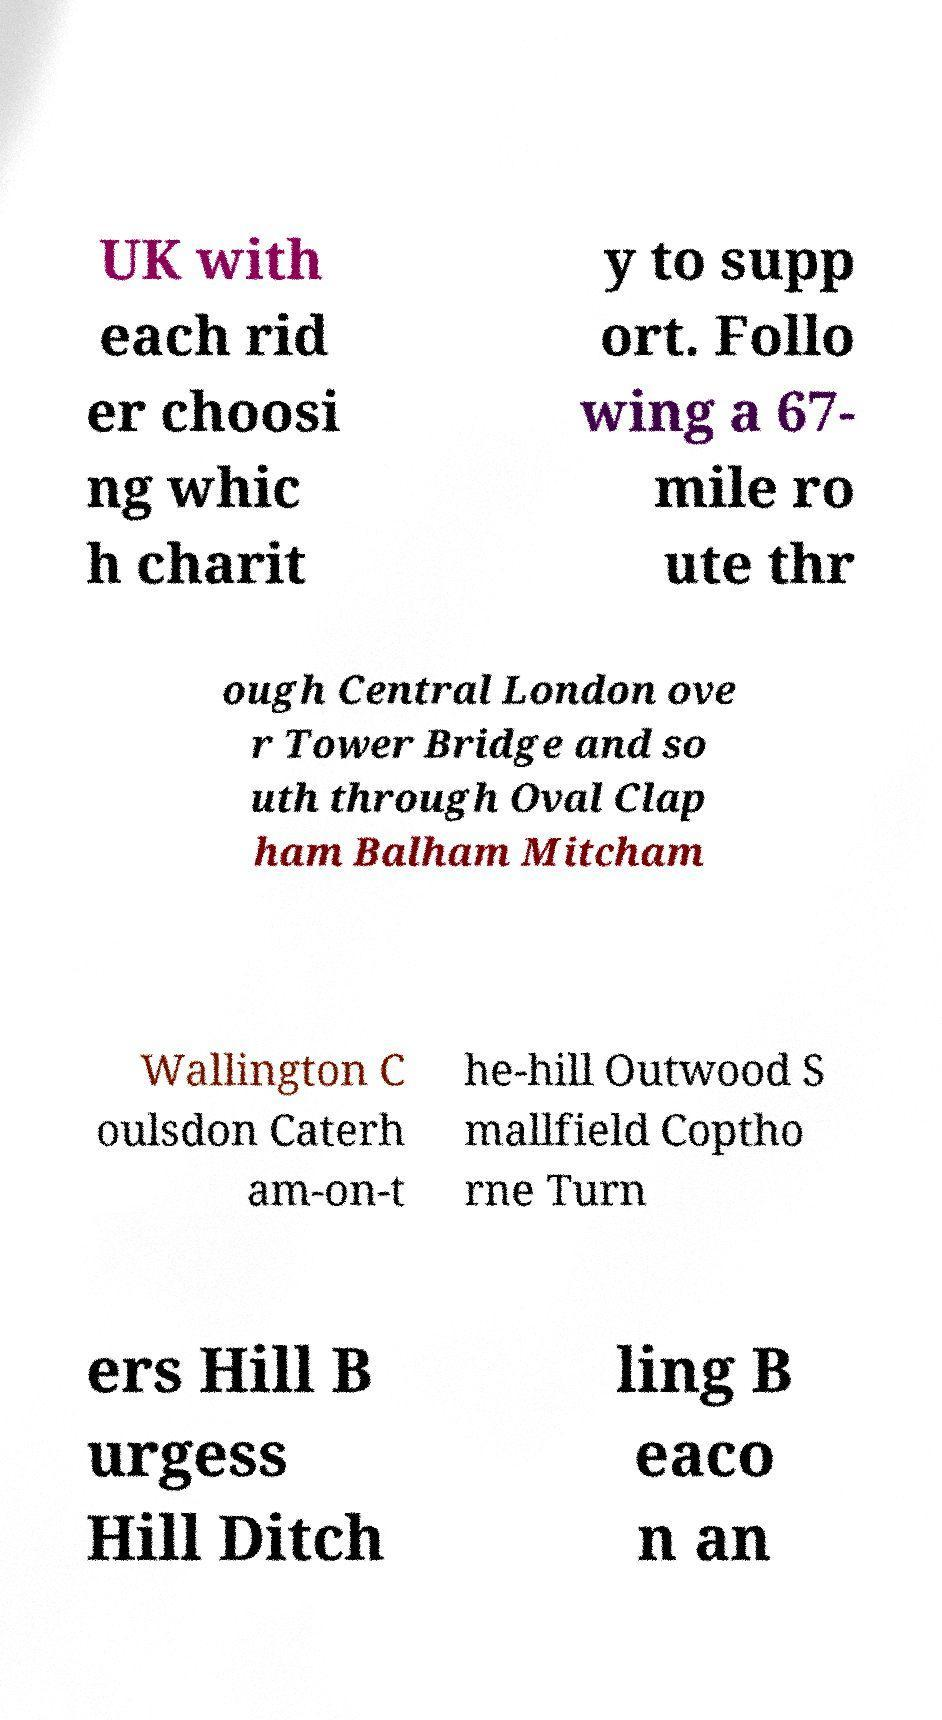Can you read and provide the text displayed in the image?This photo seems to have some interesting text. Can you extract and type it out for me? UK with each rid er choosi ng whic h charit y to supp ort. Follo wing a 67- mile ro ute thr ough Central London ove r Tower Bridge and so uth through Oval Clap ham Balham Mitcham Wallington C oulsdon Caterh am-on-t he-hill Outwood S mallfield Coptho rne Turn ers Hill B urgess Hill Ditch ling B eaco n an 